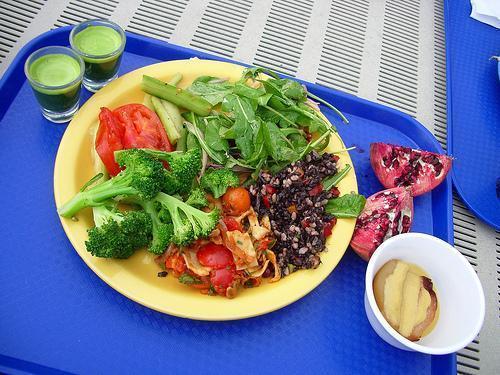How many trays are visible?
Give a very brief answer. 2. How many pieces of pomegranates are on the tray?
Give a very brief answer. 2. 